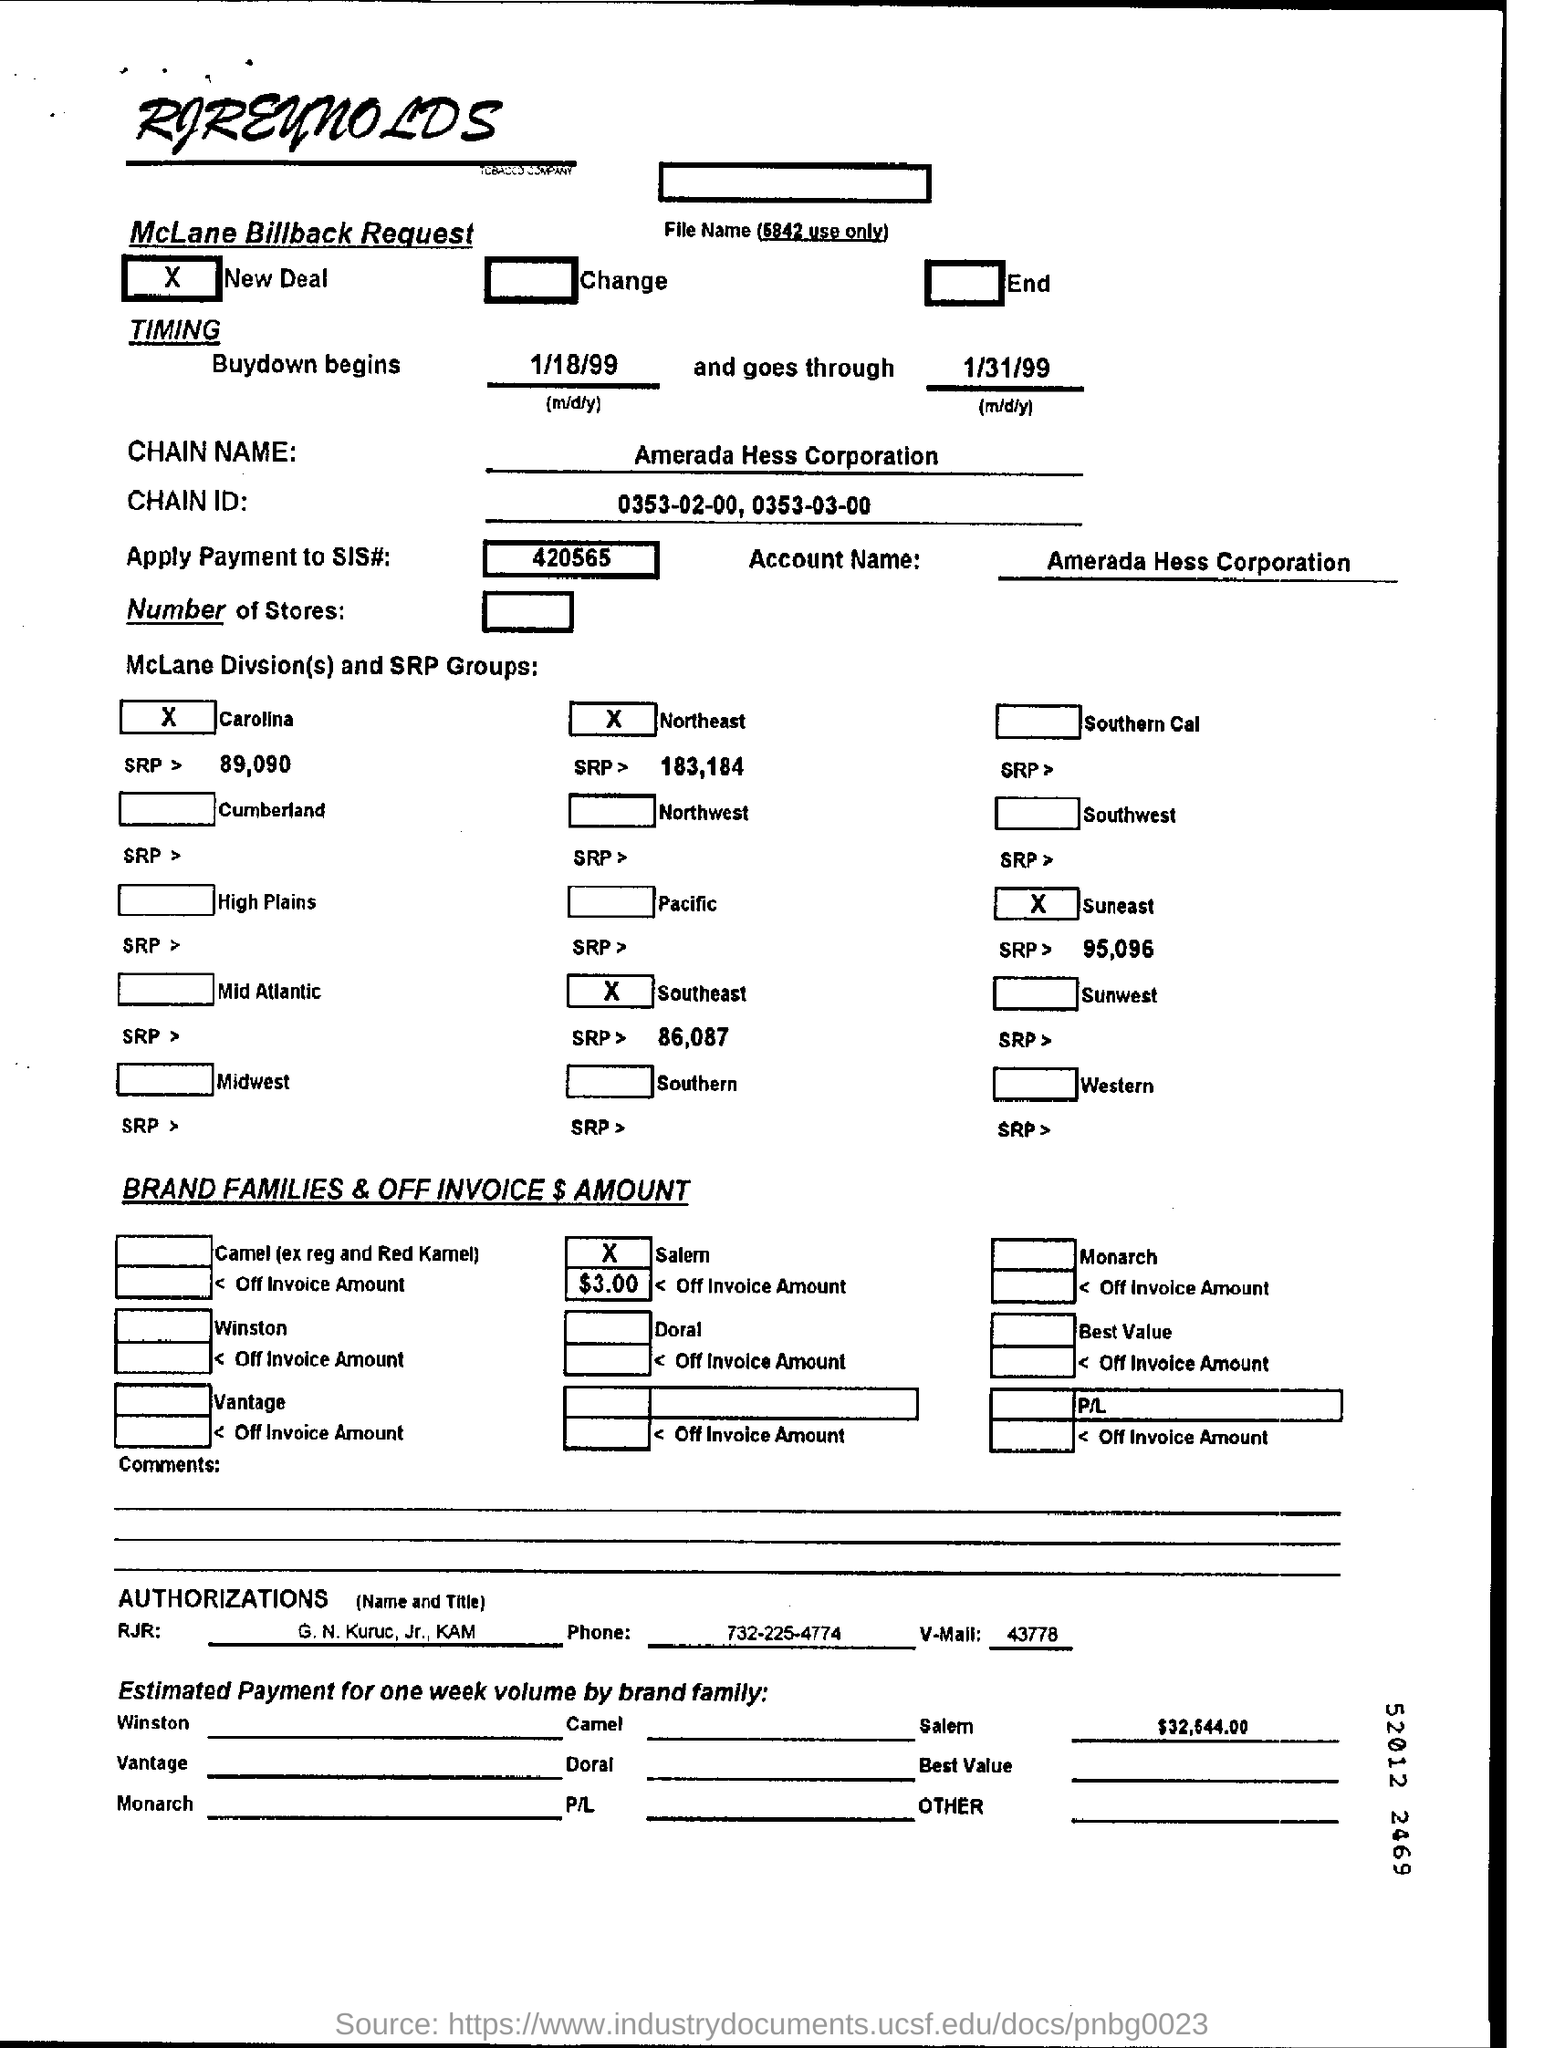List a handful of essential elements in this visual. The company named Amerada Hess Corporation is the subject of this declaration. The name of the company that is at the top of the page is RJReynolds. 